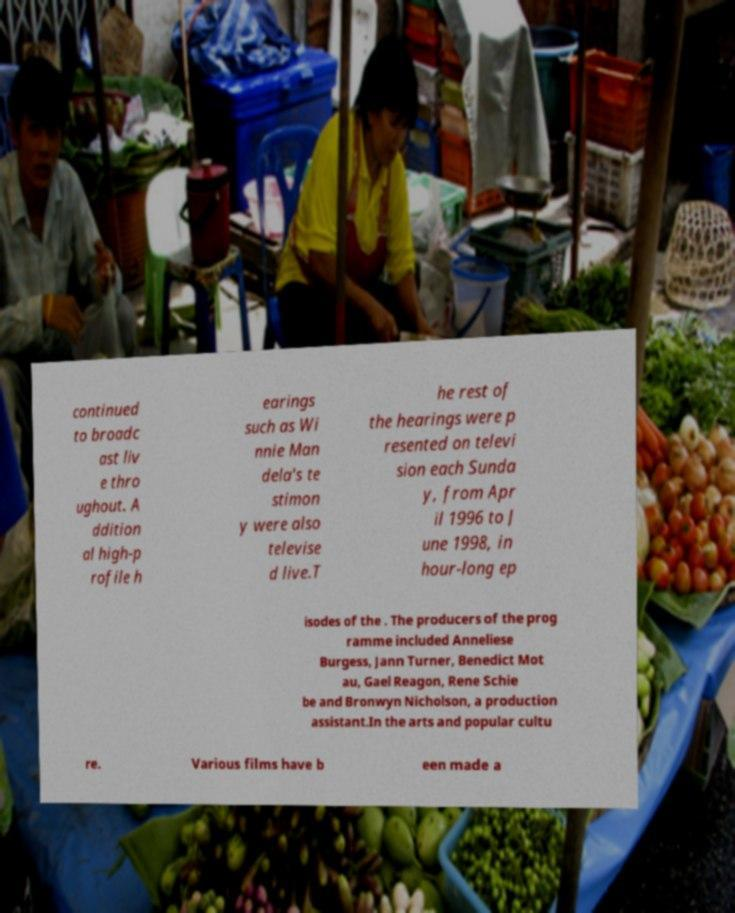I need the written content from this picture converted into text. Can you do that? continued to broadc ast liv e thro ughout. A ddition al high-p rofile h earings such as Wi nnie Man dela's te stimon y were also televise d live.T he rest of the hearings were p resented on televi sion each Sunda y, from Apr il 1996 to J une 1998, in hour-long ep isodes of the . The producers of the prog ramme included Anneliese Burgess, Jann Turner, Benedict Mot au, Gael Reagon, Rene Schie be and Bronwyn Nicholson, a production assistant.In the arts and popular cultu re. Various films have b een made a 